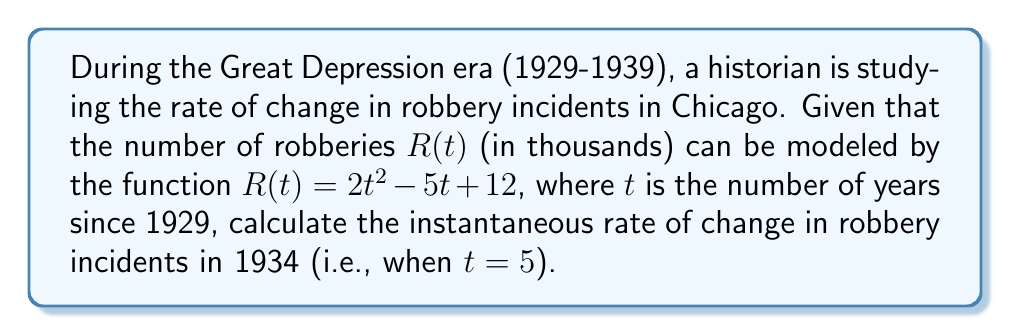Show me your answer to this math problem. To solve this problem, we need to find the derivative of the given function and evaluate it at $t = 5$. This will give us the instantaneous rate of change in robbery incidents in 1934.

1. The given function is $R(t) = 2t^2 - 5t + 12$

2. To find the rate of change, we need to calculate the derivative $R'(t)$:
   $$R'(t) = \frac{d}{dt}(2t^2 - 5t + 12)$$
   $$R'(t) = 4t - 5$$

3. Now, we need to evaluate $R'(t)$ at $t = 5$:
   $$R'(5) = 4(5) - 5$$
   $$R'(5) = 20 - 5 = 15$$

4. The units of the result are in thousands of robberies per year, as the original function $R(t)$ was given in thousands.
Answer: The instantaneous rate of change in robbery incidents in Chicago in 1934 (5 years after 1929) was 15,000 robberies per year. 